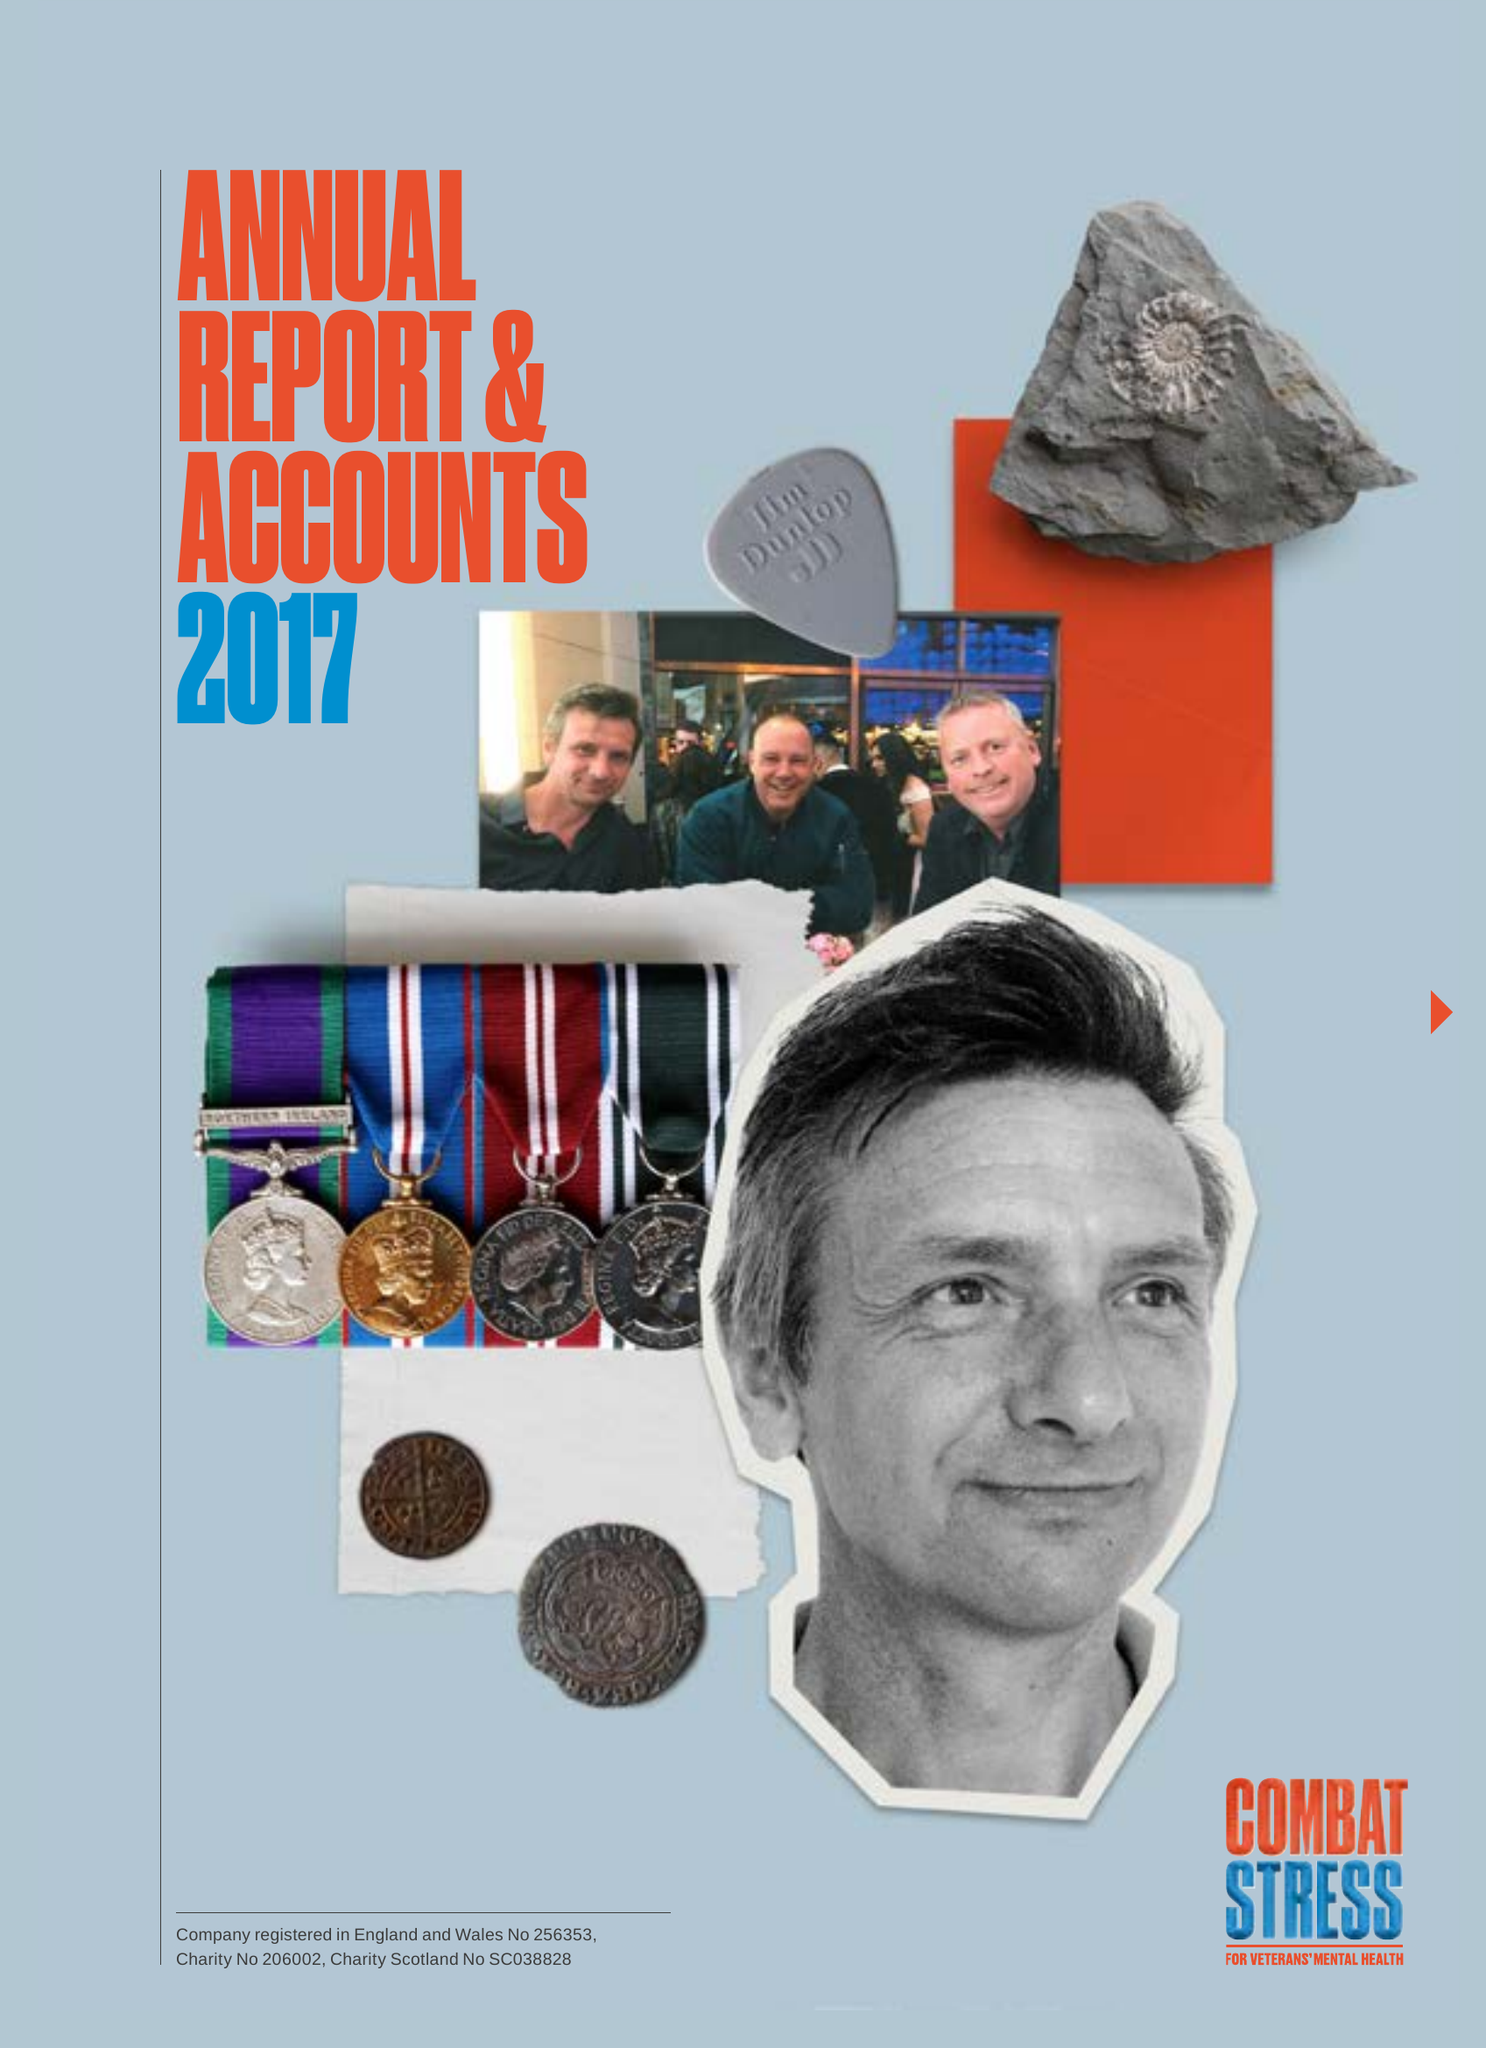What is the value for the charity_number?
Answer the question using a single word or phrase. 206002 